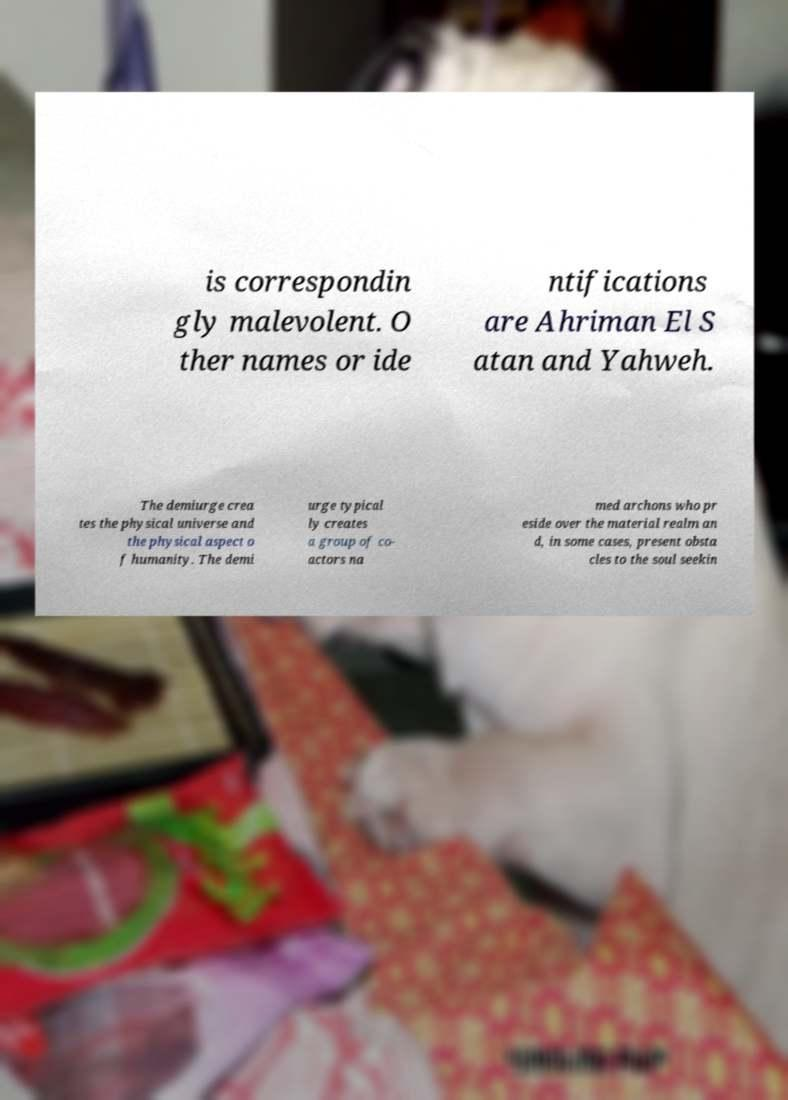For documentation purposes, I need the text within this image transcribed. Could you provide that? is correspondin gly malevolent. O ther names or ide ntifications are Ahriman El S atan and Yahweh. The demiurge crea tes the physical universe and the physical aspect o f humanity. The demi urge typical ly creates a group of co- actors na med archons who pr eside over the material realm an d, in some cases, present obsta cles to the soul seekin 